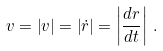<formula> <loc_0><loc_0><loc_500><loc_500>v = \left | { v } \right | = \left | { \dot { r } } \right | = \left | { \frac { d { r } } { d t } } \right | \, .</formula> 